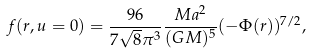<formula> <loc_0><loc_0><loc_500><loc_500>f ( r , u = 0 ) = \frac { 9 6 } { 7 \sqrt { 8 } { \pi } ^ { 3 } } \frac { M a ^ { 2 } } { ( G M ) ^ { 5 } } ( - \Phi ( r ) ) ^ { 7 / 2 } ,</formula> 